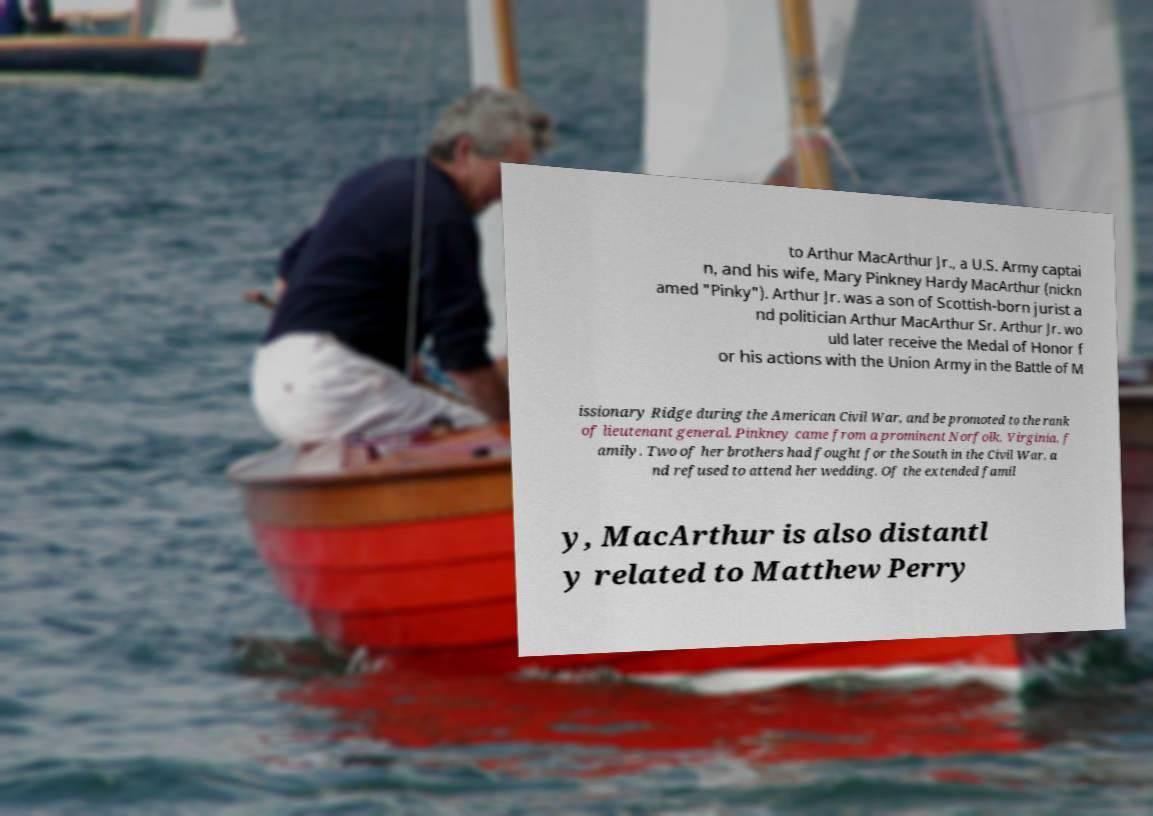Could you assist in decoding the text presented in this image and type it out clearly? to Arthur MacArthur Jr., a U.S. Army captai n, and his wife, Mary Pinkney Hardy MacArthur (nickn amed "Pinky"). Arthur Jr. was a son of Scottish-born jurist a nd politician Arthur MacArthur Sr. Arthur Jr. wo uld later receive the Medal of Honor f or his actions with the Union Army in the Battle of M issionary Ridge during the American Civil War, and be promoted to the rank of lieutenant general. Pinkney came from a prominent Norfolk, Virginia, f amily. Two of her brothers had fought for the South in the Civil War, a nd refused to attend her wedding. Of the extended famil y, MacArthur is also distantl y related to Matthew Perry 